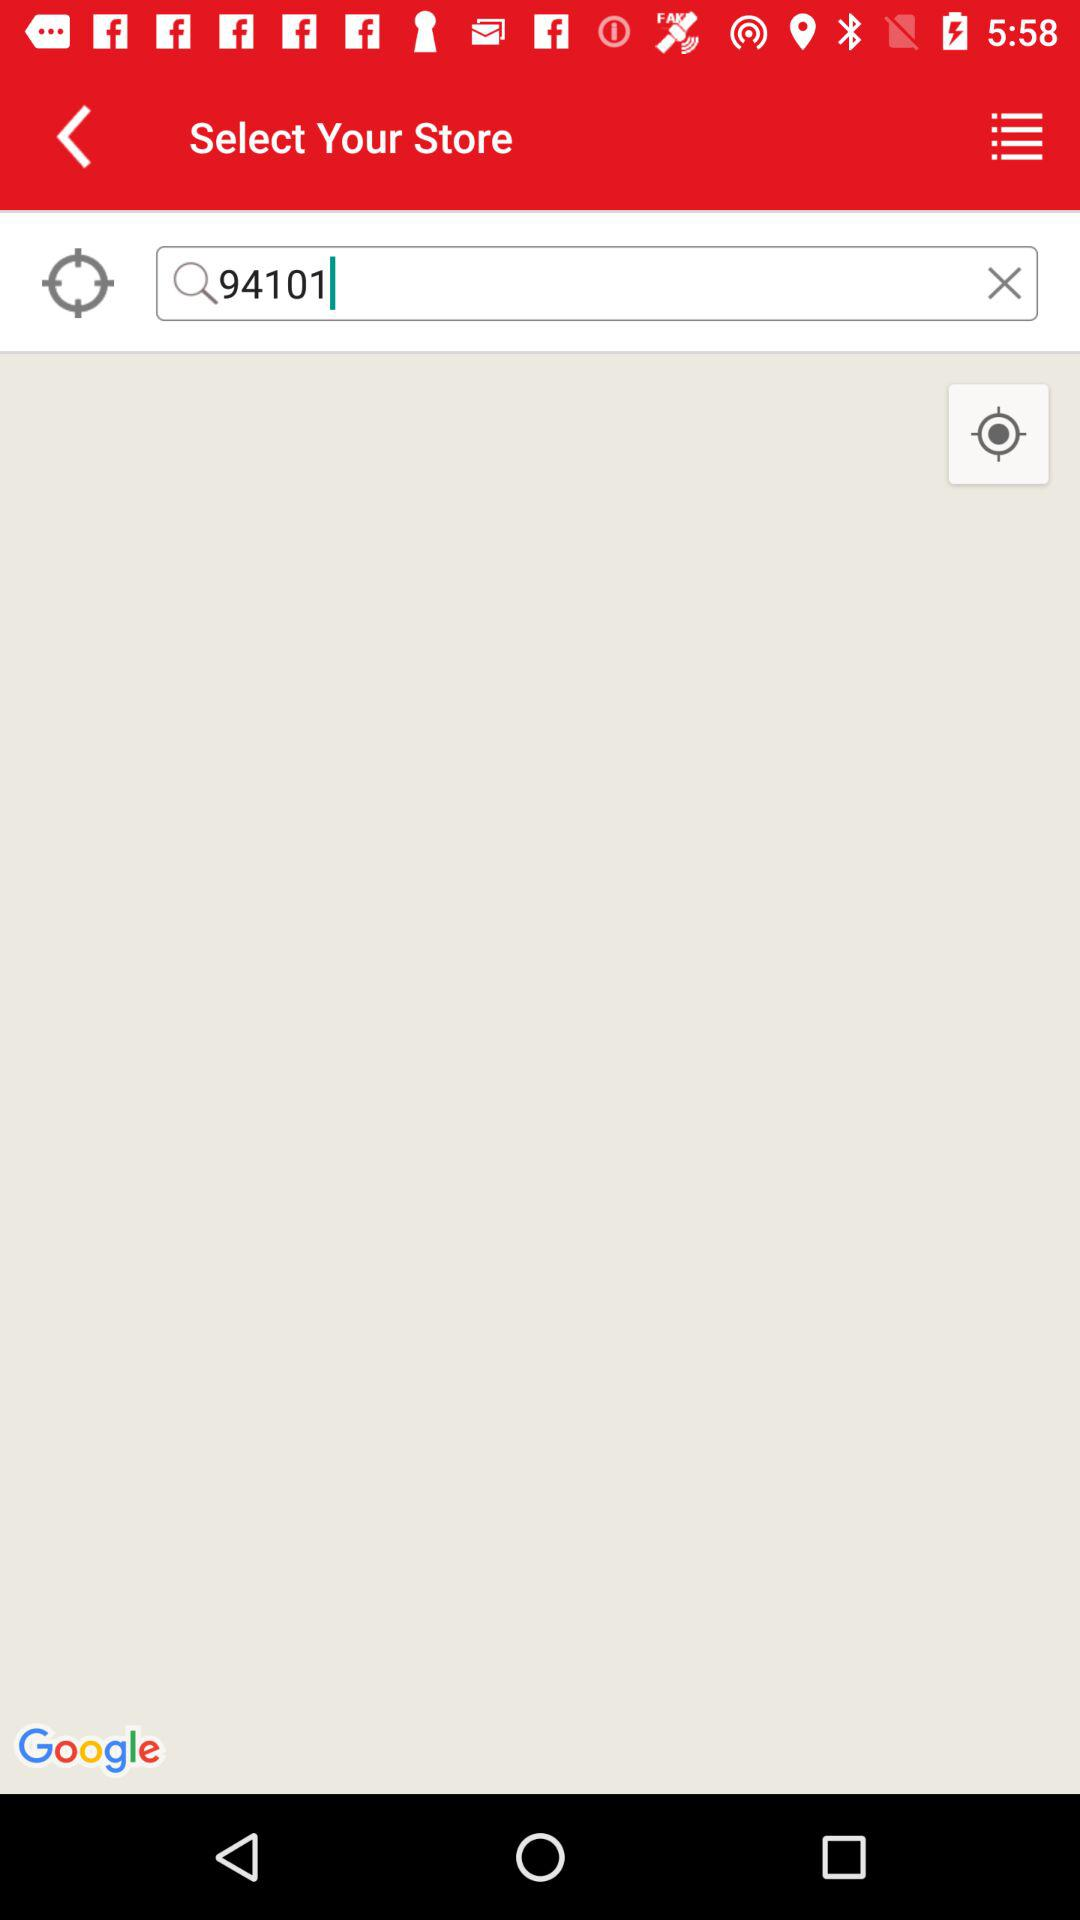What value is entered into the search bar? The value 94101 is entered into the search bar. 